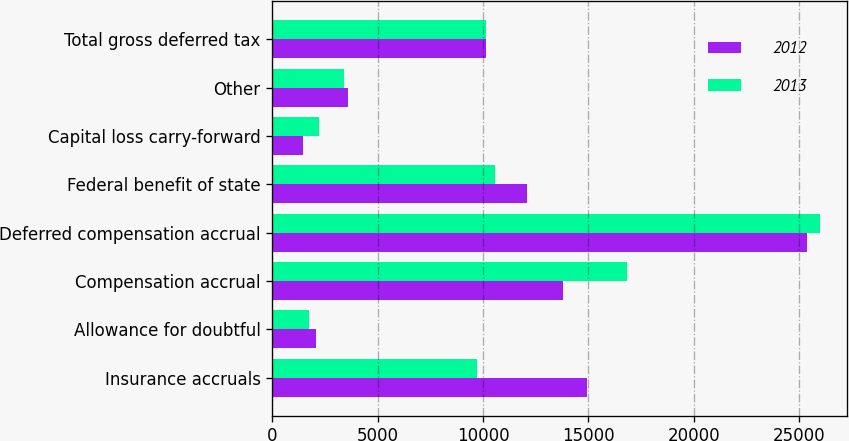<chart> <loc_0><loc_0><loc_500><loc_500><stacked_bar_chart><ecel><fcel>Insurance accruals<fcel>Allowance for doubtful<fcel>Compensation accrual<fcel>Deferred compensation accrual<fcel>Federal benefit of state<fcel>Capital loss carry-forward<fcel>Other<fcel>Total gross deferred tax<nl><fcel>2012<fcel>14938<fcel>2077<fcel>13783<fcel>25398<fcel>12099<fcel>1443<fcel>3586<fcel>10149.5<nl><fcel>2013<fcel>9713<fcel>1715<fcel>16851<fcel>25997<fcel>10586<fcel>2197<fcel>3403<fcel>10149.5<nl></chart> 